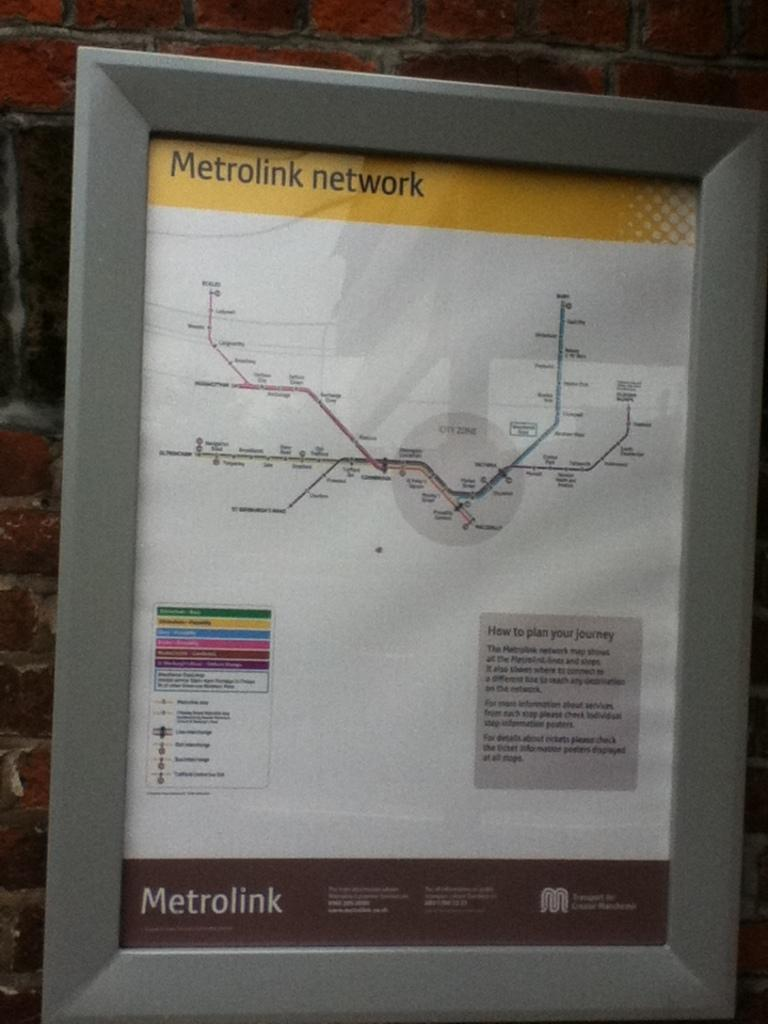<image>
Offer a succinct explanation of the picture presented. An information poster displays line information for the Metrolink system. 